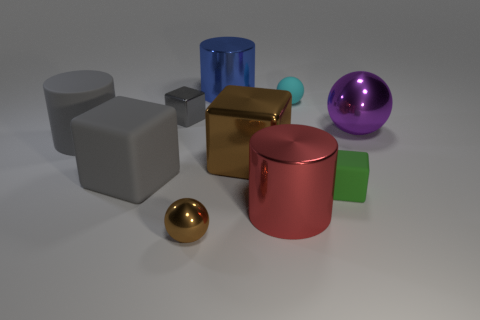Are there fewer large things than red metallic cylinders?
Offer a very short reply. No. Are there any large cylinders that have the same material as the small green object?
Ensure brevity in your answer.  Yes. The large metal thing behind the purple object has what shape?
Your answer should be compact. Cylinder. Is the color of the tiny ball that is in front of the big brown cube the same as the matte sphere?
Offer a very short reply. No. Is the number of big blue cylinders to the right of the tiny rubber block less than the number of yellow things?
Your answer should be very brief. No. There is another big cylinder that is the same material as the big blue cylinder; what color is it?
Keep it short and to the point. Red. How big is the metallic cylinder left of the red metal cylinder?
Give a very brief answer. Large. Is the material of the gray cylinder the same as the tiny cyan sphere?
Make the answer very short. Yes. There is a rubber block that is left of the brown object that is behind the tiny green rubber block; are there any gray things that are behind it?
Provide a succinct answer. Yes. What is the color of the matte sphere?
Offer a terse response. Cyan. 